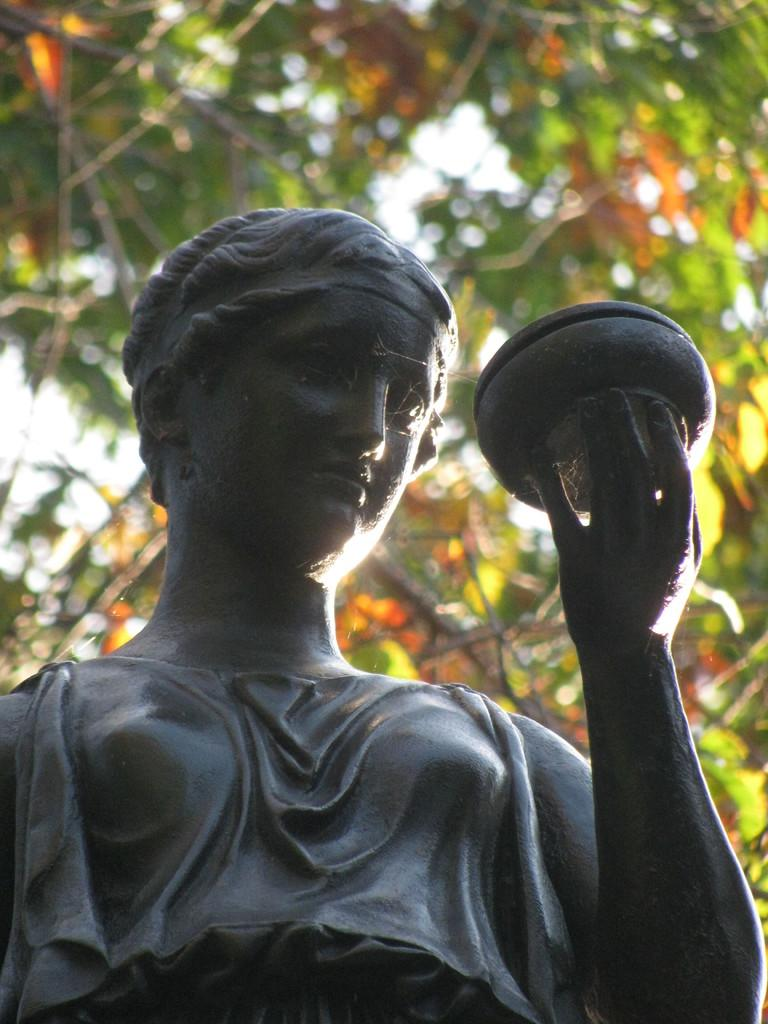What is the main subject in the middle of the image? There is a statue in the middle of the image. What is the statue holding? The statue is holding a bowl. What type of vegetation can be seen at the top of the image? There are leaves visible at the top of the image. Can you tell me how many snails are crawling on the statue in the image? There are no snails present in the image; the statue is holding a bowl. What type of agreement was reached during the party depicted in the image? There is no party depicted in the image; it features a statue holding a bowl and leaves at the top. 